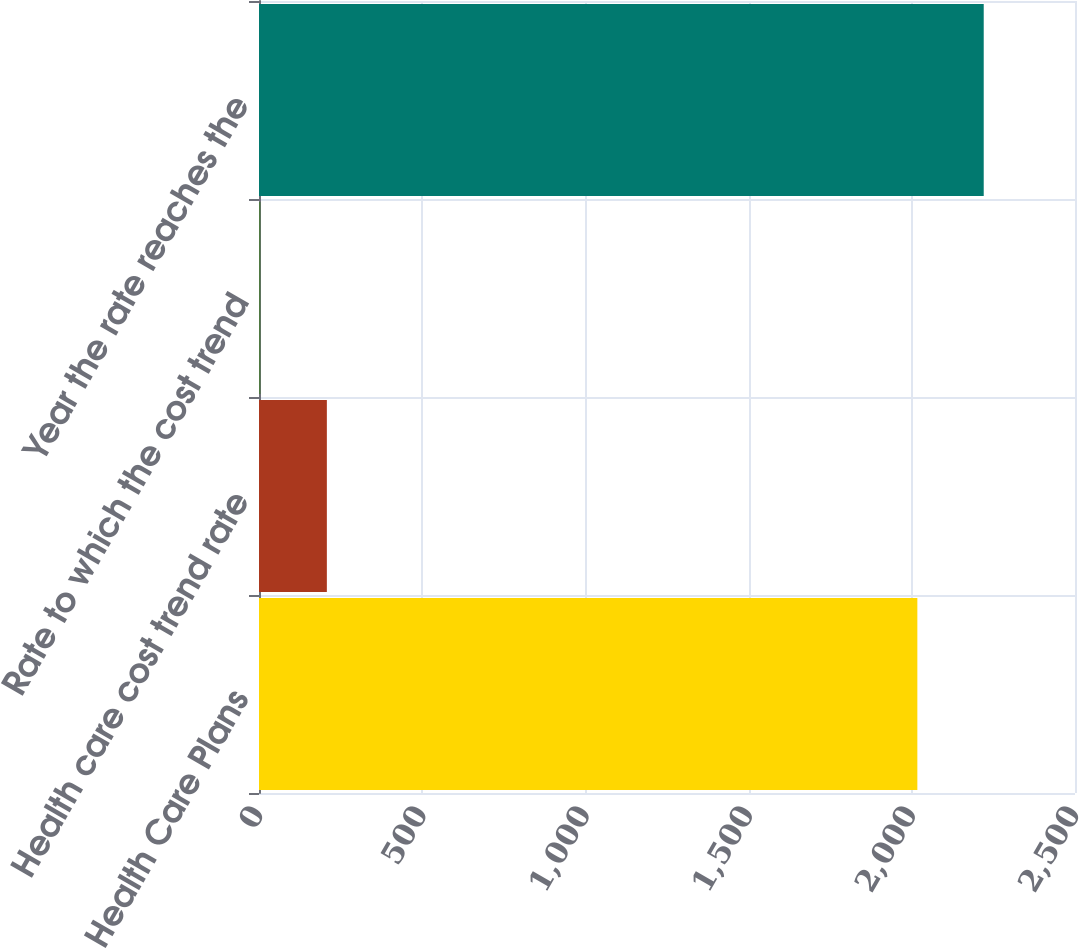Convert chart to OTSL. <chart><loc_0><loc_0><loc_500><loc_500><bar_chart><fcel>Health Care Plans<fcel>Health care cost trend rate<fcel>Rate to which the cost trend<fcel>Year the rate reaches the<nl><fcel>2017<fcel>207.9<fcel>4.55<fcel>2220.35<nl></chart> 